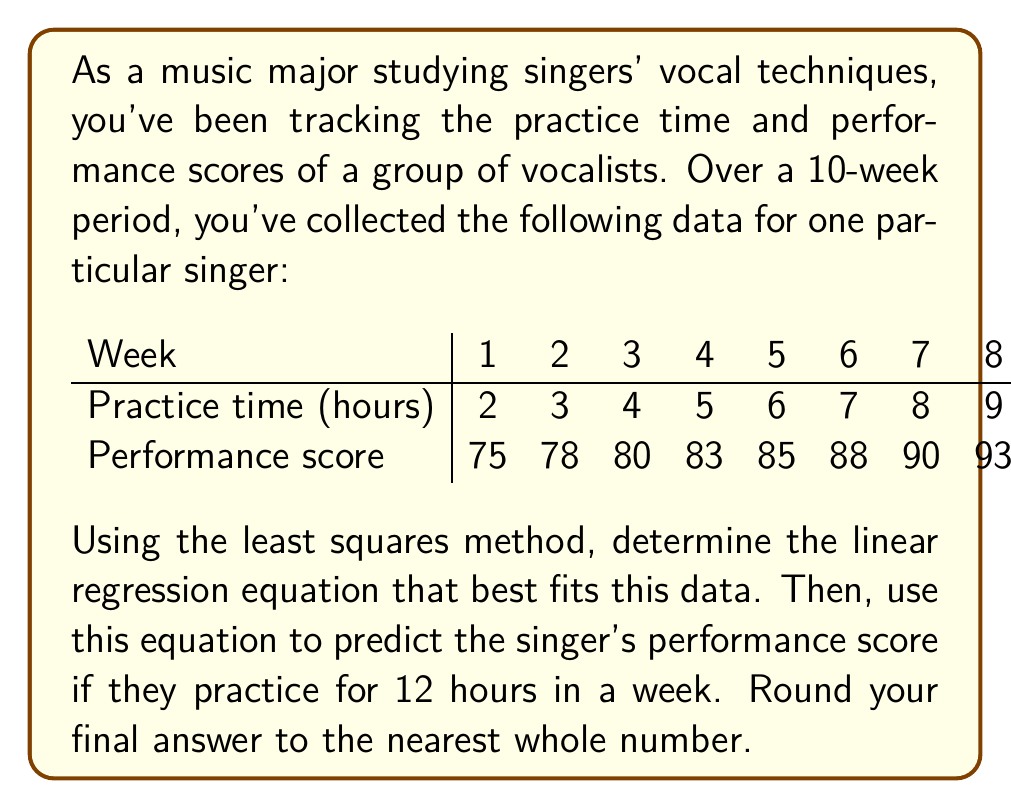Provide a solution to this math problem. To find the linear regression equation and make a prediction, we'll follow these steps:

1) First, we need to calculate some preliminary values:
   $n = 10$ (number of data points)
   $\sum x = 55$ (sum of practice hours)
   $\sum y = 865$ (sum of performance scores)
   $\sum x^2 = 385$ (sum of squared practice hours)
   $\sum xy = 5115$ (sum of products of x and y)

2) Now we can calculate the slope (m) and y-intercept (b) of the regression line using these formulas:

   $m = \frac{n\sum xy - \sum x \sum y}{n\sum x^2 - (\sum x)^2}$

   $b = \frac{\sum y - m\sum x}{n}$

3) Let's substitute our values:

   $m = \frac{10(5115) - 55(865)}{10(385) - 55^2}$
      $= \frac{51150 - 47575}{3850 - 3025}$
      $= \frac{3575}{825}$
      $= 4.33333...$

   $b = \frac{865 - 4.33333(55)}{10}$
      $= \frac{865 - 238.33333}{10}$
      $= 62.66667$

4) Our linear regression equation is:
   $y = 4.33333x + 62.66667$

5) To predict the performance score for 12 hours of practice, we substitute x = 12:
   $y = 4.33333(12) + 62.66667$
   $y = 52 + 62.66667$
   $y = 114.66667$

6) Rounding to the nearest whole number:
   $y \approx 115$
Answer: The predicted performance score for 12 hours of practice is 115. 